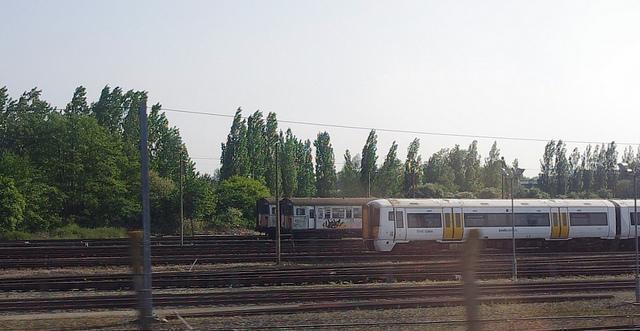During which time of the year are these trains operating?
Select the correct answer and articulate reasoning with the following format: 'Answer: answer
Rationale: rationale.'
Options: Winter, fall, summer, spring. Answer: summer.
Rationale: It doesn't look cold. 